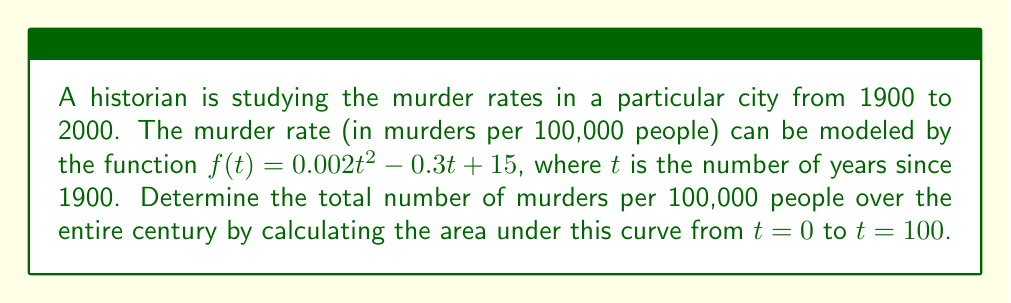Give your solution to this math problem. To find the area under the curve, we need to integrate the function $f(t)$ from $t=0$ to $t=100$. Let's break this down step-by-step:

1) The function we need to integrate is:
   $f(t) = 0.002t^2 - 0.3t + 15$

2) We need to find:
   $\int_0^{100} (0.002t^2 - 0.3t + 15) dt$

3) Let's integrate each term:
   
   $\int 0.002t^2 dt = \frac{0.002t^3}{3}$
   
   $\int -0.3t dt = -0.15t^2$
   
   $\int 15 dt = 15t$

4) Now our integral becomes:
   $[\frac{0.002t^3}{3} - 0.15t^2 + 15t]_0^{100}$

5) Let's evaluate this from 0 to 100:

   At $t=100$: 
   $\frac{0.002(100^3)}{3} - 0.15(100^2) + 15(100) = 666.67 - 1500 + 1500 = 666.67$

   At $t=0$: 
   $\frac{0.002(0^3)}{3} - 0.15(0^2) + 15(0) = 0$

6) The final result is the difference:
   $666.67 - 0 = 666.67$

Therefore, the total number of murders per 100,000 people over the century is approximately 666.67.
Answer: $666.67$ murders per 100,000 people 